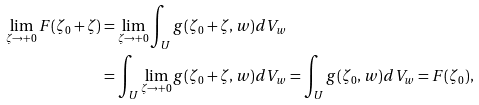Convert formula to latex. <formula><loc_0><loc_0><loc_500><loc_500>\lim _ { \zeta \to + 0 } F ( \zeta _ { 0 } + \zeta ) & = \lim _ { \zeta \to + 0 } \int _ { U } g ( \zeta _ { 0 } + \zeta , w ) d V _ { w } \\ & = \int _ { U } \lim _ { \zeta \to + 0 } g ( \zeta _ { 0 } + \zeta , w ) d V _ { w } = \int _ { U } g ( \zeta _ { 0 } , w ) d V _ { w } = F ( \zeta _ { 0 } ) ,</formula> 